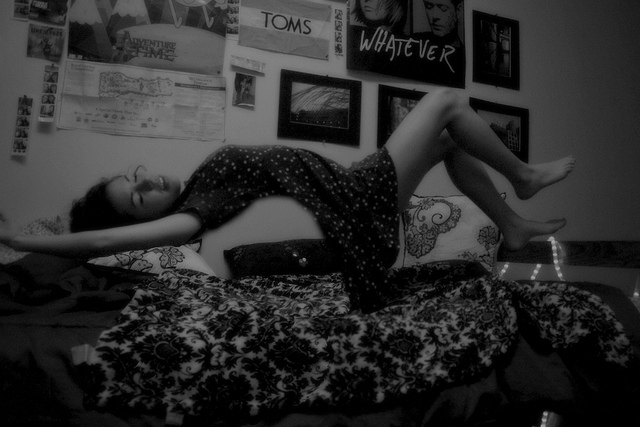Identify and read out the text in this image. TIME TOMS WHATEVER 